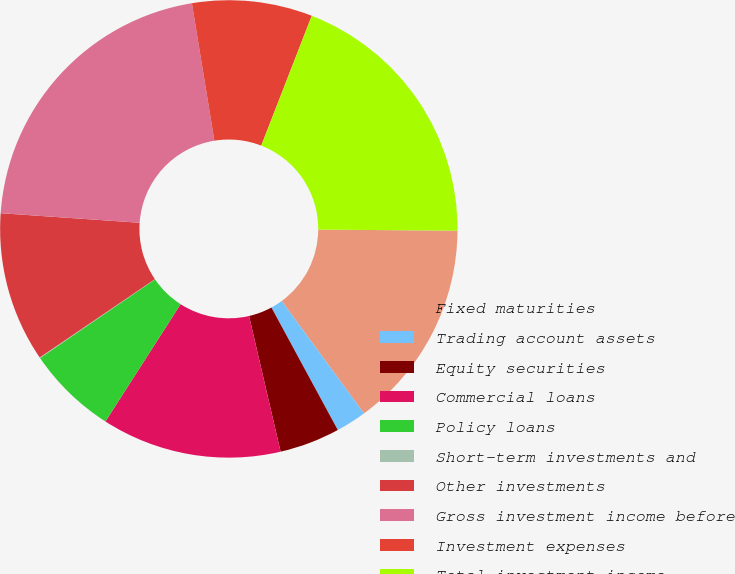<chart> <loc_0><loc_0><loc_500><loc_500><pie_chart><fcel>Fixed maturities<fcel>Trading account assets<fcel>Equity securities<fcel>Commercial loans<fcel>Policy loans<fcel>Short-term investments and<fcel>Other investments<fcel>Gross investment income before<fcel>Investment expenses<fcel>Total investment income<nl><fcel>14.82%<fcel>2.16%<fcel>4.27%<fcel>12.71%<fcel>6.38%<fcel>0.05%<fcel>10.6%<fcel>21.33%<fcel>8.49%<fcel>19.22%<nl></chart> 